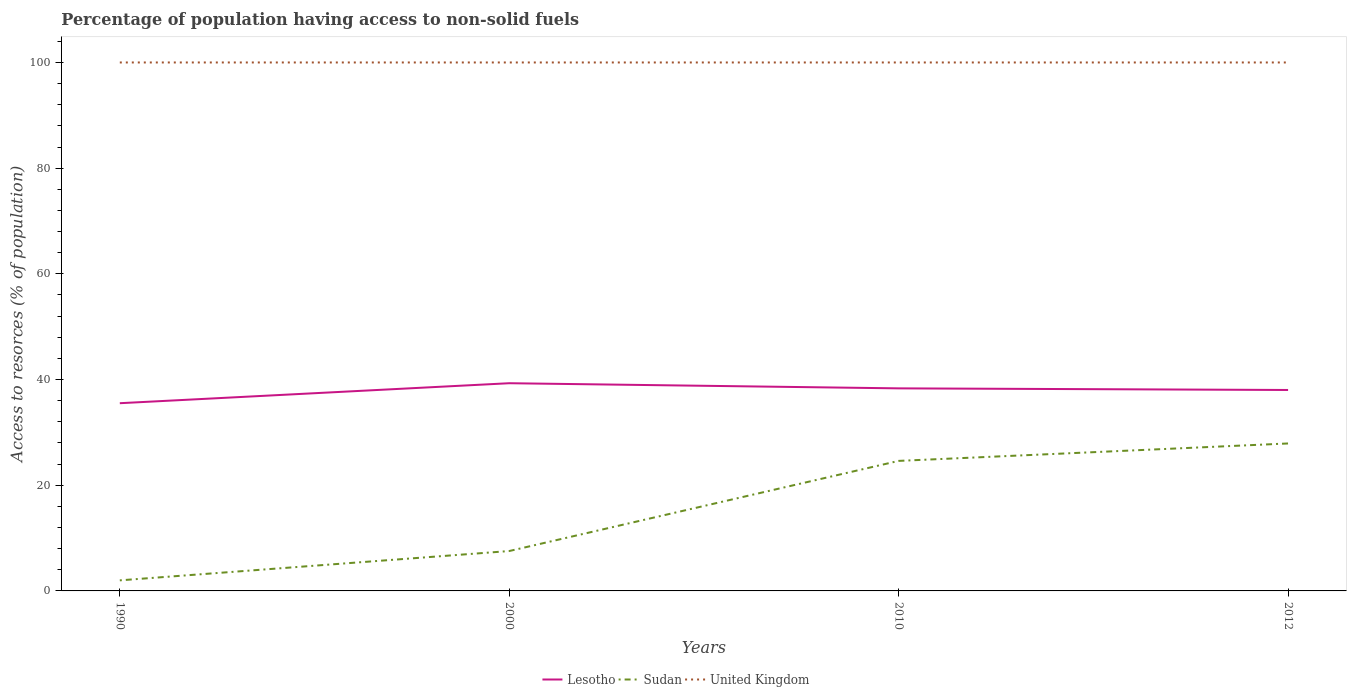Across all years, what is the maximum percentage of population having access to non-solid fuels in Lesotho?
Provide a short and direct response. 35.52. In which year was the percentage of population having access to non-solid fuels in Lesotho maximum?
Offer a very short reply. 1990. What is the total percentage of population having access to non-solid fuels in United Kingdom in the graph?
Ensure brevity in your answer.  0. What is the difference between the highest and the second highest percentage of population having access to non-solid fuels in Sudan?
Provide a short and direct response. 25.9. Is the percentage of population having access to non-solid fuels in United Kingdom strictly greater than the percentage of population having access to non-solid fuels in Lesotho over the years?
Your response must be concise. No. What is the difference between two consecutive major ticks on the Y-axis?
Your answer should be compact. 20. Does the graph contain any zero values?
Make the answer very short. No. Does the graph contain grids?
Provide a succinct answer. No. Where does the legend appear in the graph?
Make the answer very short. Bottom center. How many legend labels are there?
Offer a very short reply. 3. How are the legend labels stacked?
Provide a short and direct response. Horizontal. What is the title of the graph?
Keep it short and to the point. Percentage of population having access to non-solid fuels. What is the label or title of the X-axis?
Offer a very short reply. Years. What is the label or title of the Y-axis?
Provide a succinct answer. Access to resorces (% of population). What is the Access to resorces (% of population) of Lesotho in 1990?
Provide a short and direct response. 35.52. What is the Access to resorces (% of population) of Sudan in 1990?
Your response must be concise. 2. What is the Access to resorces (% of population) in United Kingdom in 1990?
Your answer should be very brief. 100. What is the Access to resorces (% of population) of Lesotho in 2000?
Provide a succinct answer. 39.3. What is the Access to resorces (% of population) of Sudan in 2000?
Provide a short and direct response. 7.55. What is the Access to resorces (% of population) of Lesotho in 2010?
Provide a succinct answer. 38.33. What is the Access to resorces (% of population) in Sudan in 2010?
Ensure brevity in your answer.  24.6. What is the Access to resorces (% of population) of Lesotho in 2012?
Keep it short and to the point. 38.02. What is the Access to resorces (% of population) of Sudan in 2012?
Your answer should be very brief. 27.9. What is the Access to resorces (% of population) of United Kingdom in 2012?
Keep it short and to the point. 100. Across all years, what is the maximum Access to resorces (% of population) of Lesotho?
Provide a short and direct response. 39.3. Across all years, what is the maximum Access to resorces (% of population) in Sudan?
Provide a succinct answer. 27.9. Across all years, what is the maximum Access to resorces (% of population) in United Kingdom?
Your answer should be compact. 100. Across all years, what is the minimum Access to resorces (% of population) in Lesotho?
Ensure brevity in your answer.  35.52. Across all years, what is the minimum Access to resorces (% of population) in Sudan?
Provide a short and direct response. 2. What is the total Access to resorces (% of population) in Lesotho in the graph?
Offer a terse response. 151.18. What is the total Access to resorces (% of population) in Sudan in the graph?
Offer a terse response. 62.06. What is the total Access to resorces (% of population) in United Kingdom in the graph?
Offer a terse response. 400. What is the difference between the Access to resorces (% of population) of Lesotho in 1990 and that in 2000?
Give a very brief answer. -3.78. What is the difference between the Access to resorces (% of population) in Sudan in 1990 and that in 2000?
Give a very brief answer. -5.55. What is the difference between the Access to resorces (% of population) in Lesotho in 1990 and that in 2010?
Offer a terse response. -2.81. What is the difference between the Access to resorces (% of population) in Sudan in 1990 and that in 2010?
Provide a short and direct response. -22.6. What is the difference between the Access to resorces (% of population) of Lesotho in 1990 and that in 2012?
Ensure brevity in your answer.  -2.5. What is the difference between the Access to resorces (% of population) of Sudan in 1990 and that in 2012?
Your response must be concise. -25.9. What is the difference between the Access to resorces (% of population) in Lesotho in 2000 and that in 2010?
Offer a terse response. 0.97. What is the difference between the Access to resorces (% of population) in Sudan in 2000 and that in 2010?
Keep it short and to the point. -17.06. What is the difference between the Access to resorces (% of population) of United Kingdom in 2000 and that in 2010?
Give a very brief answer. 0. What is the difference between the Access to resorces (% of population) in Lesotho in 2000 and that in 2012?
Keep it short and to the point. 1.28. What is the difference between the Access to resorces (% of population) of Sudan in 2000 and that in 2012?
Ensure brevity in your answer.  -20.36. What is the difference between the Access to resorces (% of population) in Lesotho in 2010 and that in 2012?
Your answer should be compact. 0.31. What is the difference between the Access to resorces (% of population) in Sudan in 2010 and that in 2012?
Provide a short and direct response. -3.3. What is the difference between the Access to resorces (% of population) of Lesotho in 1990 and the Access to resorces (% of population) of Sudan in 2000?
Provide a short and direct response. 27.97. What is the difference between the Access to resorces (% of population) in Lesotho in 1990 and the Access to resorces (% of population) in United Kingdom in 2000?
Ensure brevity in your answer.  -64.48. What is the difference between the Access to resorces (% of population) in Sudan in 1990 and the Access to resorces (% of population) in United Kingdom in 2000?
Give a very brief answer. -98. What is the difference between the Access to resorces (% of population) in Lesotho in 1990 and the Access to resorces (% of population) in Sudan in 2010?
Provide a short and direct response. 10.92. What is the difference between the Access to resorces (% of population) of Lesotho in 1990 and the Access to resorces (% of population) of United Kingdom in 2010?
Provide a succinct answer. -64.48. What is the difference between the Access to resorces (% of population) of Sudan in 1990 and the Access to resorces (% of population) of United Kingdom in 2010?
Provide a succinct answer. -98. What is the difference between the Access to resorces (% of population) in Lesotho in 1990 and the Access to resorces (% of population) in Sudan in 2012?
Your answer should be compact. 7.62. What is the difference between the Access to resorces (% of population) of Lesotho in 1990 and the Access to resorces (% of population) of United Kingdom in 2012?
Give a very brief answer. -64.48. What is the difference between the Access to resorces (% of population) in Sudan in 1990 and the Access to resorces (% of population) in United Kingdom in 2012?
Your answer should be very brief. -98. What is the difference between the Access to resorces (% of population) in Lesotho in 2000 and the Access to resorces (% of population) in Sudan in 2010?
Provide a short and direct response. 14.7. What is the difference between the Access to resorces (% of population) of Lesotho in 2000 and the Access to resorces (% of population) of United Kingdom in 2010?
Ensure brevity in your answer.  -60.7. What is the difference between the Access to resorces (% of population) of Sudan in 2000 and the Access to resorces (% of population) of United Kingdom in 2010?
Your response must be concise. -92.45. What is the difference between the Access to resorces (% of population) in Lesotho in 2000 and the Access to resorces (% of population) in Sudan in 2012?
Offer a very short reply. 11.4. What is the difference between the Access to resorces (% of population) of Lesotho in 2000 and the Access to resorces (% of population) of United Kingdom in 2012?
Offer a terse response. -60.7. What is the difference between the Access to resorces (% of population) of Sudan in 2000 and the Access to resorces (% of population) of United Kingdom in 2012?
Make the answer very short. -92.45. What is the difference between the Access to resorces (% of population) of Lesotho in 2010 and the Access to resorces (% of population) of Sudan in 2012?
Your response must be concise. 10.43. What is the difference between the Access to resorces (% of population) of Lesotho in 2010 and the Access to resorces (% of population) of United Kingdom in 2012?
Offer a very short reply. -61.67. What is the difference between the Access to resorces (% of population) in Sudan in 2010 and the Access to resorces (% of population) in United Kingdom in 2012?
Your answer should be compact. -75.4. What is the average Access to resorces (% of population) of Lesotho per year?
Keep it short and to the point. 37.79. What is the average Access to resorces (% of population) in Sudan per year?
Make the answer very short. 15.51. In the year 1990, what is the difference between the Access to resorces (% of population) of Lesotho and Access to resorces (% of population) of Sudan?
Provide a short and direct response. 33.52. In the year 1990, what is the difference between the Access to resorces (% of population) in Lesotho and Access to resorces (% of population) in United Kingdom?
Your answer should be very brief. -64.48. In the year 1990, what is the difference between the Access to resorces (% of population) of Sudan and Access to resorces (% of population) of United Kingdom?
Offer a terse response. -98. In the year 2000, what is the difference between the Access to resorces (% of population) of Lesotho and Access to resorces (% of population) of Sudan?
Provide a short and direct response. 31.76. In the year 2000, what is the difference between the Access to resorces (% of population) of Lesotho and Access to resorces (% of population) of United Kingdom?
Give a very brief answer. -60.7. In the year 2000, what is the difference between the Access to resorces (% of population) in Sudan and Access to resorces (% of population) in United Kingdom?
Offer a terse response. -92.45. In the year 2010, what is the difference between the Access to resorces (% of population) in Lesotho and Access to resorces (% of population) in Sudan?
Make the answer very short. 13.72. In the year 2010, what is the difference between the Access to resorces (% of population) in Lesotho and Access to resorces (% of population) in United Kingdom?
Provide a succinct answer. -61.67. In the year 2010, what is the difference between the Access to resorces (% of population) in Sudan and Access to resorces (% of population) in United Kingdom?
Give a very brief answer. -75.4. In the year 2012, what is the difference between the Access to resorces (% of population) of Lesotho and Access to resorces (% of population) of Sudan?
Offer a very short reply. 10.12. In the year 2012, what is the difference between the Access to resorces (% of population) of Lesotho and Access to resorces (% of population) of United Kingdom?
Offer a terse response. -61.98. In the year 2012, what is the difference between the Access to resorces (% of population) in Sudan and Access to resorces (% of population) in United Kingdom?
Provide a short and direct response. -72.1. What is the ratio of the Access to resorces (% of population) of Lesotho in 1990 to that in 2000?
Make the answer very short. 0.9. What is the ratio of the Access to resorces (% of population) in Sudan in 1990 to that in 2000?
Give a very brief answer. 0.27. What is the ratio of the Access to resorces (% of population) in United Kingdom in 1990 to that in 2000?
Keep it short and to the point. 1. What is the ratio of the Access to resorces (% of population) of Lesotho in 1990 to that in 2010?
Offer a very short reply. 0.93. What is the ratio of the Access to resorces (% of population) in Sudan in 1990 to that in 2010?
Your answer should be compact. 0.08. What is the ratio of the Access to resorces (% of population) of Lesotho in 1990 to that in 2012?
Provide a succinct answer. 0.93. What is the ratio of the Access to resorces (% of population) of Sudan in 1990 to that in 2012?
Your response must be concise. 0.07. What is the ratio of the Access to resorces (% of population) of Lesotho in 2000 to that in 2010?
Offer a very short reply. 1.03. What is the ratio of the Access to resorces (% of population) of Sudan in 2000 to that in 2010?
Your answer should be very brief. 0.31. What is the ratio of the Access to resorces (% of population) of Lesotho in 2000 to that in 2012?
Your response must be concise. 1.03. What is the ratio of the Access to resorces (% of population) in Sudan in 2000 to that in 2012?
Provide a succinct answer. 0.27. What is the ratio of the Access to resorces (% of population) of United Kingdom in 2000 to that in 2012?
Give a very brief answer. 1. What is the ratio of the Access to resorces (% of population) in Sudan in 2010 to that in 2012?
Make the answer very short. 0.88. What is the ratio of the Access to resorces (% of population) of United Kingdom in 2010 to that in 2012?
Your response must be concise. 1. What is the difference between the highest and the second highest Access to resorces (% of population) of Lesotho?
Ensure brevity in your answer.  0.97. What is the difference between the highest and the second highest Access to resorces (% of population) in Sudan?
Keep it short and to the point. 3.3. What is the difference between the highest and the second highest Access to resorces (% of population) of United Kingdom?
Give a very brief answer. 0. What is the difference between the highest and the lowest Access to resorces (% of population) in Lesotho?
Offer a very short reply. 3.78. What is the difference between the highest and the lowest Access to resorces (% of population) of Sudan?
Offer a terse response. 25.9. 